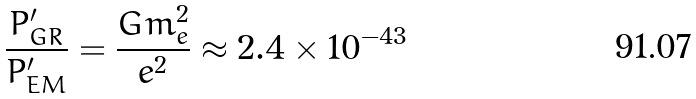<formula> <loc_0><loc_0><loc_500><loc_500>\frac { P _ { G R } ^ { \prime } } { P _ { E M } ^ { \prime } } = \frac { G m _ { e } ^ { 2 } } { e ^ { 2 } } \approx 2 . 4 \times 1 0 ^ { - 4 3 }</formula> 